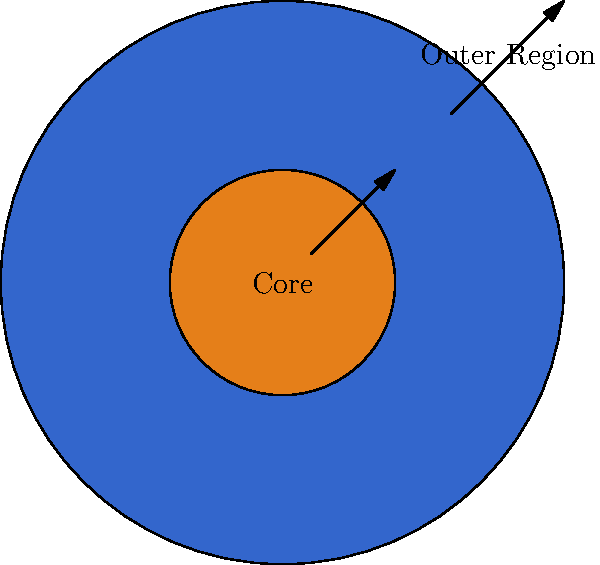In ballroom dancing, we often talk about the core and frame of a dancer. Similarly, nebulae have distinct regions. Looking at this simplified diagram of a nebula, what is the relationship between the core and outer region in terms of temperature and density? To understand the structure of a nebula, let's break it down step-by-step:

1. Core region:
   - The core is the central, brightest part of the nebula.
   - It's typically hotter and denser than the outer regions.
   - In the diagram, it's represented by the smaller, brighter central circle.

2. Outer region:
   - This is the larger, more diffuse area surrounding the core.
   - It's generally cooler and less dense than the core.
   - In the diagram, it's shown as the larger, lighter-colored area.

3. Temperature gradient:
   - Temperature decreases as we move from the core to the outer regions.
   - This is similar to how a dancer's core generates more heat during intense movement.

4. Density gradient:
   - Density also decreases from the core to the outer regions.
   - This is analogous to how a dancer's frame becomes less rigid and more fluid towards the extremities.

5. Relationship:
   - There's an inverse relationship between distance from the core and both temperature and density.
   - As you move further from the core, both temperature and density decrease.

This structure is crucial for the nebula's evolution, much like how a dancer's core and frame are essential for proper technique and movement.
Answer: Core: hotter and denser; Outer region: cooler and less dense 